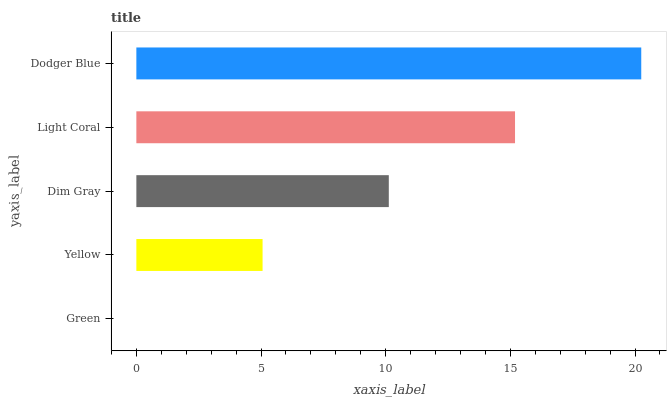Is Green the minimum?
Answer yes or no. Yes. Is Dodger Blue the maximum?
Answer yes or no. Yes. Is Yellow the minimum?
Answer yes or no. No. Is Yellow the maximum?
Answer yes or no. No. Is Yellow greater than Green?
Answer yes or no. Yes. Is Green less than Yellow?
Answer yes or no. Yes. Is Green greater than Yellow?
Answer yes or no. No. Is Yellow less than Green?
Answer yes or no. No. Is Dim Gray the high median?
Answer yes or no. Yes. Is Dim Gray the low median?
Answer yes or no. Yes. Is Dodger Blue the high median?
Answer yes or no. No. Is Dodger Blue the low median?
Answer yes or no. No. 